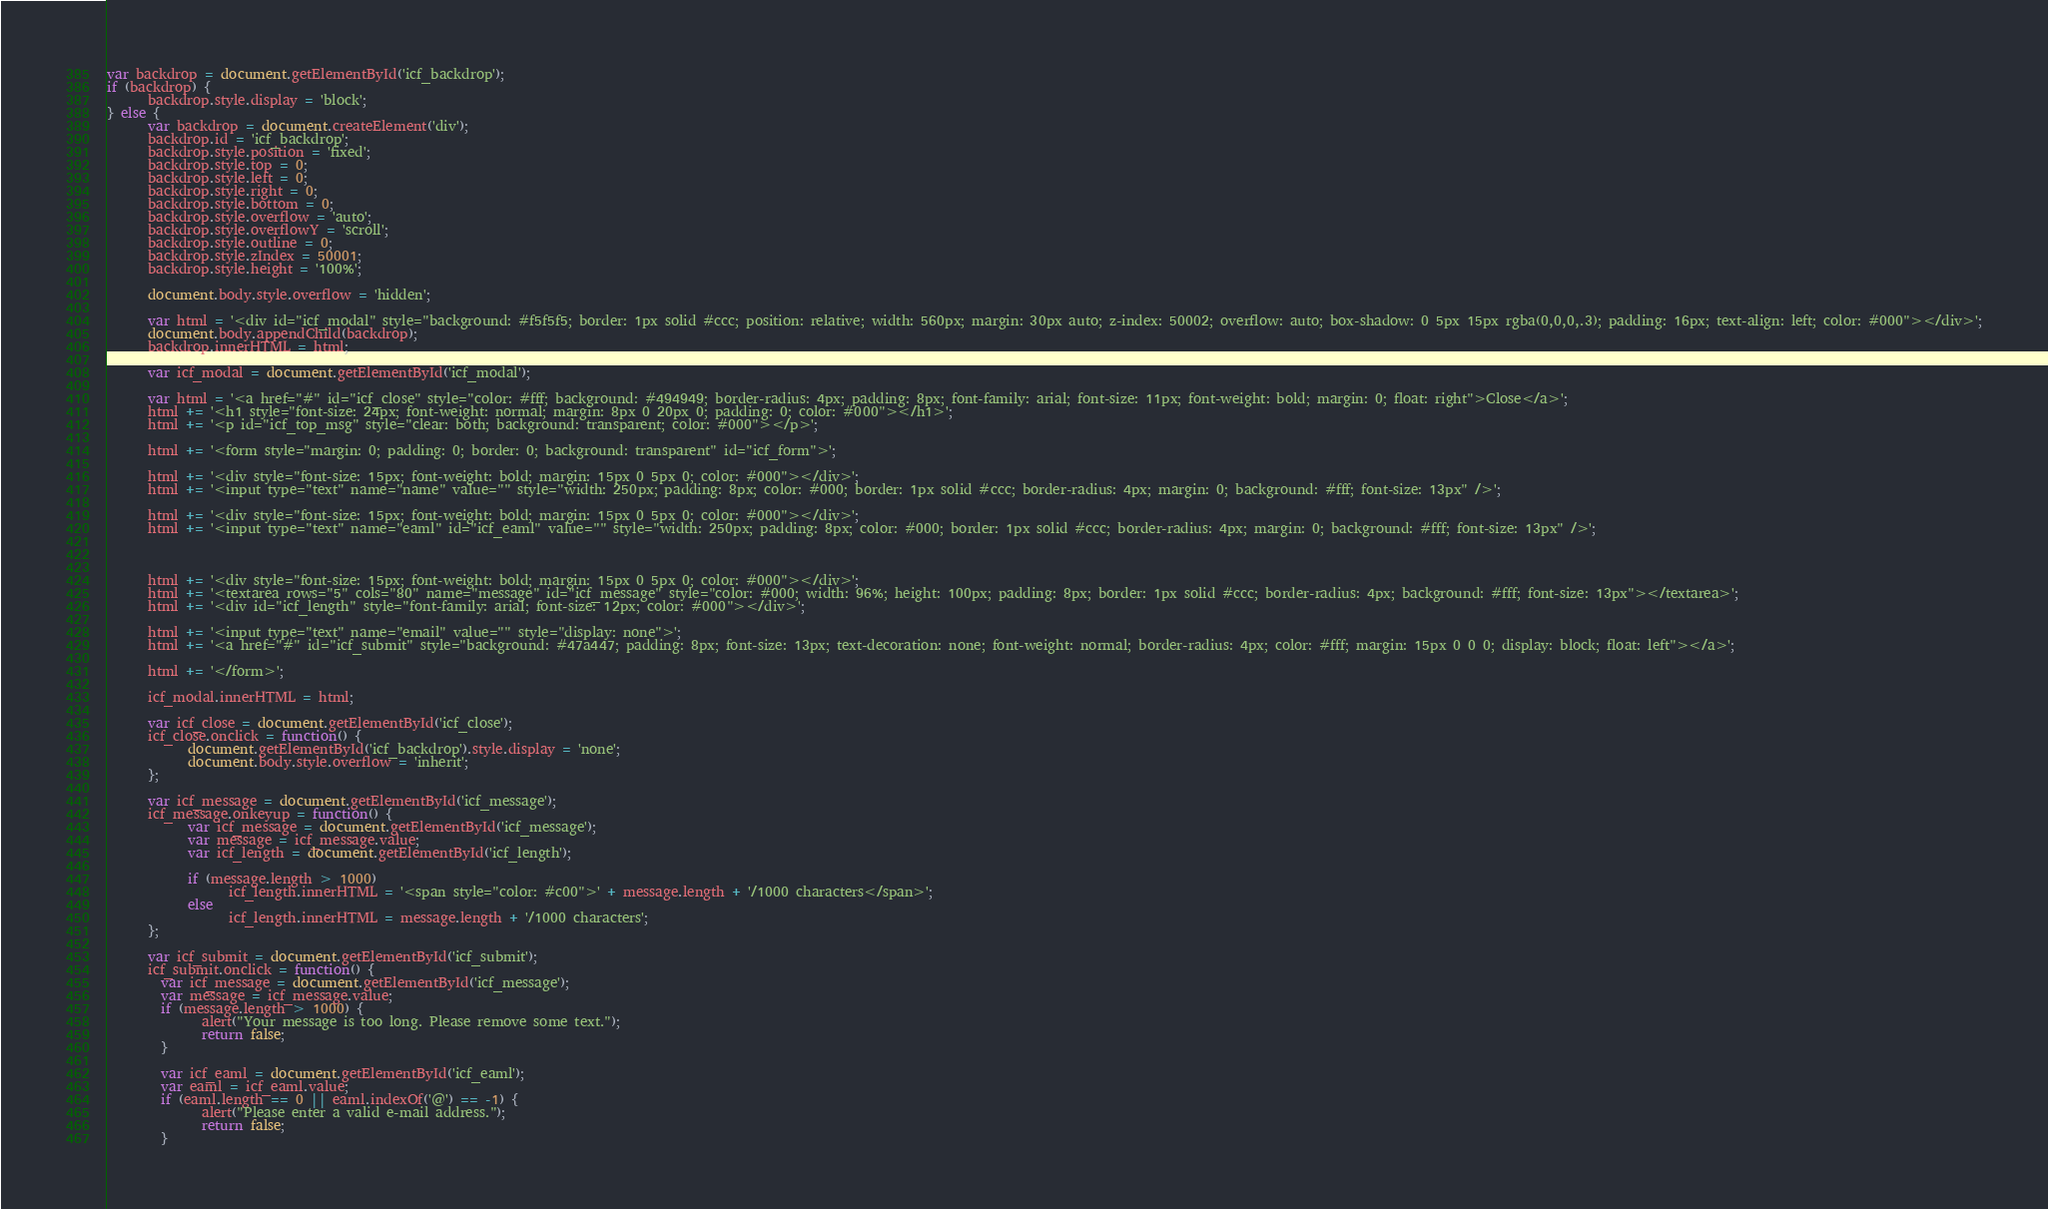Convert code to text. <code><loc_0><loc_0><loc_500><loc_500><_JavaScript_>var backdrop = document.getElementById('icf_backdrop');
if (backdrop) {
      backdrop.style.display = 'block';
} else {
      var backdrop = document.createElement('div');
      backdrop.id = 'icf_backdrop';
      backdrop.style.position = 'fixed';
      backdrop.style.top = 0;
      backdrop.style.left = 0;
      backdrop.style.right = 0;
      backdrop.style.bottom = 0;
      backdrop.style.overflow = 'auto';
      backdrop.style.overflowY = 'scroll';
      backdrop.style.outline = 0;
      backdrop.style.zIndex = 50001;
      backdrop.style.height = '100%';

      document.body.style.overflow = 'hidden';

      var html = '<div id="icf_modal" style="background: #f5f5f5; border: 1px solid #ccc; position: relative; width: 560px; margin: 30px auto; z-index: 50002; overflow: auto; box-shadow: 0 5px 15px rgba(0,0,0,.3); padding: 16px; text-align: left; color: #000"></div>';
      document.body.appendChild(backdrop);
      backdrop.innerHTML = html;

      var icf_modal = document.getElementById('icf_modal');

      var html = '<a href="#" id="icf_close" style="color: #fff; background: #494949; border-radius: 4px; padding: 8px; font-family: arial; font-size: 11px; font-weight: bold; margin: 0; float: right">Close</a>';
      html += '<h1 style="font-size: 24px; font-weight: normal; margin: 8px 0 20px 0; padding: 0; color: #000"></h1>';
      html += '<p id="icf_top_msg" style="clear: both; background: transparent; color: #000"></p>';

      html += '<form style="margin: 0; padding: 0; border: 0; background: transparent" id="icf_form">';

      html += '<div style="font-size: 15px; font-weight: bold; margin: 15px 0 5px 0; color: #000"></div>';
      html += '<input type="text" name="name" value="" style="width: 250px; padding: 8px; color: #000; border: 1px solid #ccc; border-radius: 4px; margin: 0; background: #fff; font-size: 13px" />';

      html += '<div style="font-size: 15px; font-weight: bold; margin: 15px 0 5px 0; color: #000"></div>';
      html += '<input type="text" name="eaml" id="icf_eaml" value="" style="width: 250px; padding: 8px; color: #000; border: 1px solid #ccc; border-radius: 4px; margin: 0; background: #fff; font-size: 13px" />';

      
      
      html += '<div style="font-size: 15px; font-weight: bold; margin: 15px 0 5px 0; color: #000"></div>';
      html += '<textarea rows="5" cols="80" name="message" id="icf_message" style="color: #000; width: 96%; height: 100px; padding: 8px; border: 1px solid #ccc; border-radius: 4px; background: #fff; font-size: 13px"></textarea>';
      html += '<div id="icf_length" style="font-family: arial; font-size: 12px; color: #000"></div>';

      html += '<input type="text" name="email" value="" style="display: none">';
      html += '<a href="#" id="icf_submit" style="background: #47a447; padding: 8px; font-size: 13px; text-decoration: none; font-weight: normal; border-radius: 4px; color: #fff; margin: 15px 0 0 0; display: block; float: left"></a>';
      
      html += '</form>';
      
      icf_modal.innerHTML = html;

      var icf_close = document.getElementById('icf_close');
      icf_close.onclick = function() { 
            document.getElementById('icf_backdrop').style.display = 'none';
            document.body.style.overflow = 'inherit';
      };

      var icf_message = document.getElementById('icf_message');
      icf_message.onkeyup = function() {
            var icf_message = document.getElementById('icf_message');
            var message = icf_message.value;
            var icf_length = document.getElementById('icf_length');

            if (message.length > 1000)
                  icf_length.innerHTML = '<span style="color: #c00">' + message.length + '/1000 characters</span>';
            else
                  icf_length.innerHTML = message.length + '/1000 characters';
      };

      var icf_submit = document.getElementById('icf_submit');
      icf_submit.onclick = function() {
        var icf_message = document.getElementById('icf_message');
        var message = icf_message.value;
        if (message.length > 1000) {
              alert("Your message is too long. Please remove some text.");
              return false;
        }

        var icf_eaml = document.getElementById('icf_eaml');
        var eaml = icf_eaml.value;
        if (eaml.length == 0 || eaml.indexOf('@') == -1) {
              alert("Please enter a valid e-mail address.");
              return false;
        }
</code> 